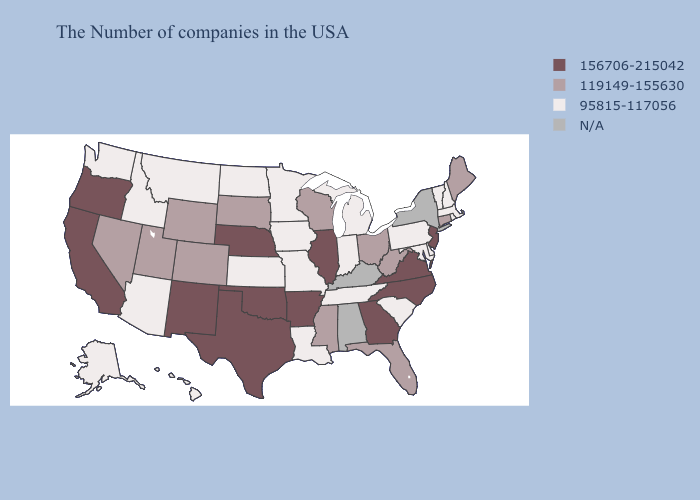Is the legend a continuous bar?
Be succinct. No. Name the states that have a value in the range 156706-215042?
Write a very short answer. New Jersey, Virginia, North Carolina, Georgia, Illinois, Arkansas, Nebraska, Oklahoma, Texas, New Mexico, California, Oregon. What is the lowest value in states that border Indiana?
Concise answer only. 95815-117056. What is the value of Tennessee?
Give a very brief answer. 95815-117056. Among the states that border North Dakota , which have the highest value?
Be succinct. South Dakota. What is the value of Iowa?
Give a very brief answer. 95815-117056. What is the value of Delaware?
Quick response, please. 95815-117056. What is the highest value in the South ?
Answer briefly. 156706-215042. Name the states that have a value in the range 119149-155630?
Keep it brief. Maine, Connecticut, West Virginia, Ohio, Florida, Wisconsin, Mississippi, South Dakota, Wyoming, Colorado, Utah, Nevada. What is the value of Oregon?
Be succinct. 156706-215042. Name the states that have a value in the range 95815-117056?
Quick response, please. Massachusetts, Rhode Island, New Hampshire, Vermont, Delaware, Maryland, Pennsylvania, South Carolina, Michigan, Indiana, Tennessee, Louisiana, Missouri, Minnesota, Iowa, Kansas, North Dakota, Montana, Arizona, Idaho, Washington, Alaska, Hawaii. Which states have the lowest value in the South?
Be succinct. Delaware, Maryland, South Carolina, Tennessee, Louisiana. What is the value of Iowa?
Short answer required. 95815-117056. Does Pennsylvania have the lowest value in the USA?
Answer briefly. Yes. 